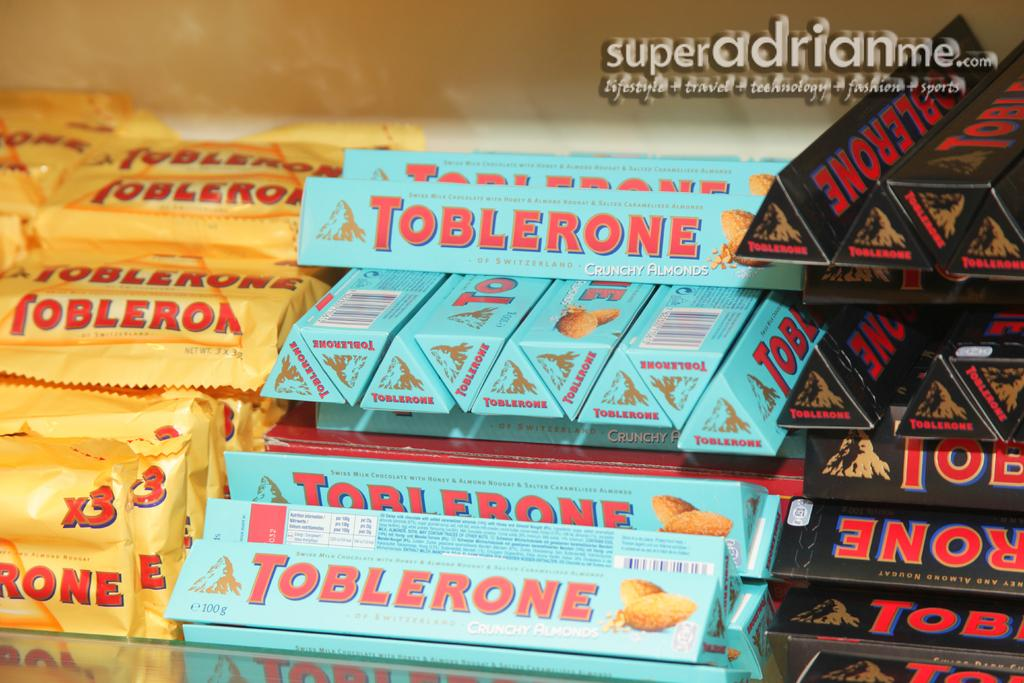<image>
Relay a brief, clear account of the picture shown. A display of toblerones in blue, black and yellow. 